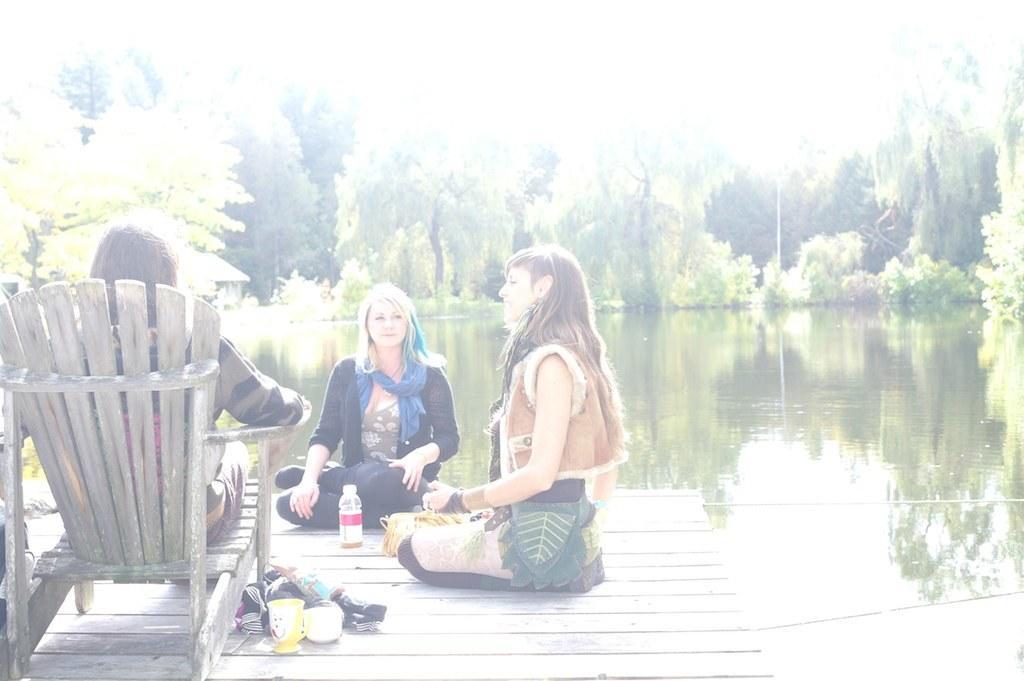Describe this image in one or two sentences. A person is sitting on the chair. Two women are sitting at here she is wearing a sweater shirt and also she is smiling. 